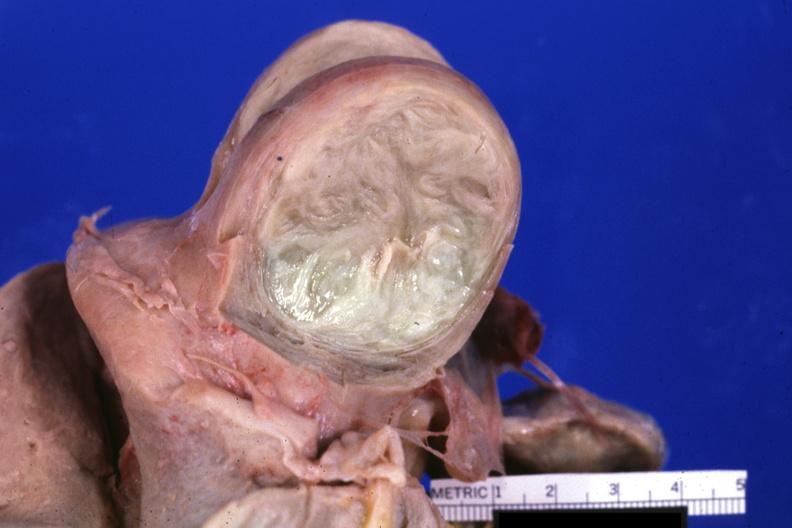s fixed tissue cut surface of typical myoma?
Answer the question using a single word or phrase. Yes 